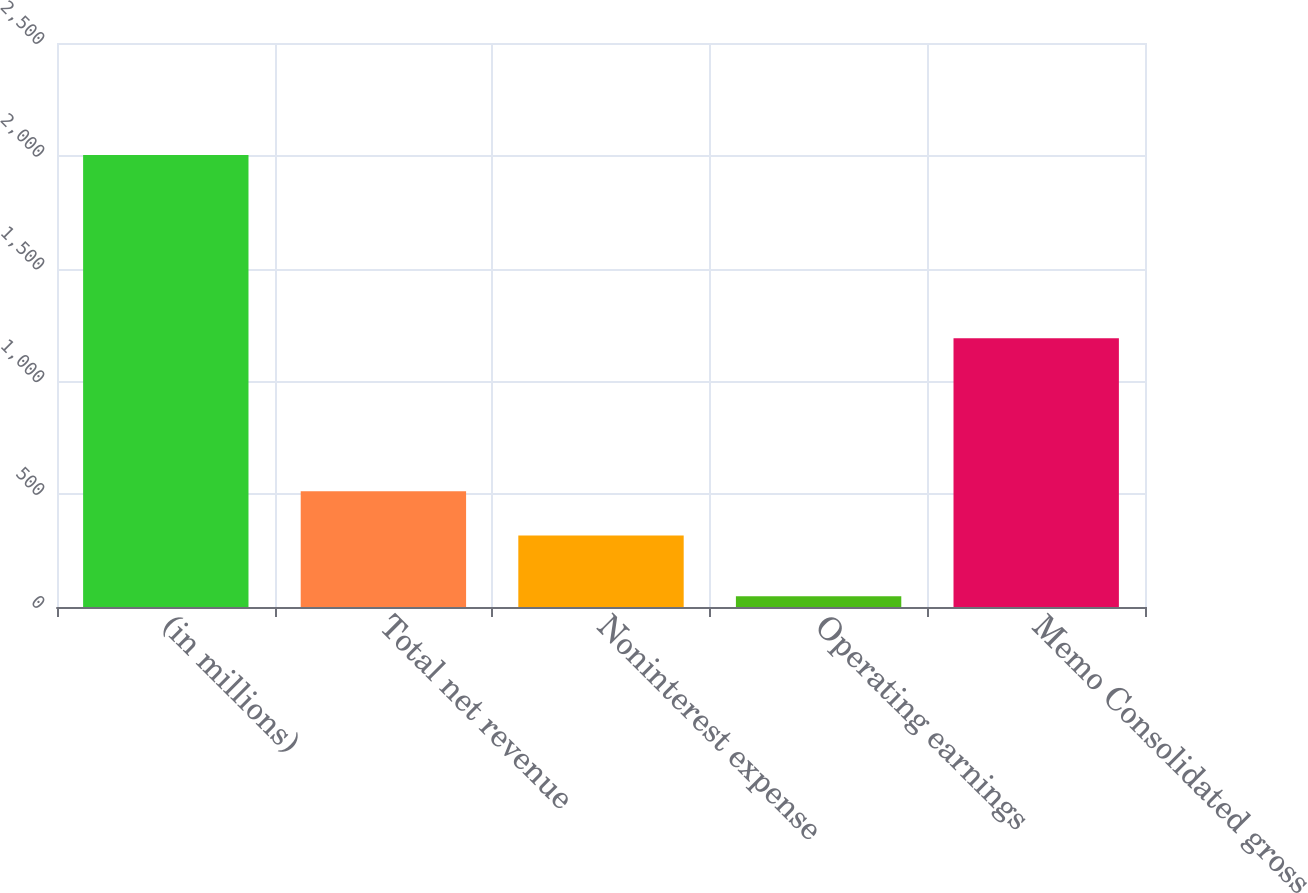<chart> <loc_0><loc_0><loc_500><loc_500><bar_chart><fcel>(in millions)<fcel>Total net revenue<fcel>Noninterest expense<fcel>Operating earnings<fcel>Memo Consolidated gross<nl><fcel>2004<fcel>512.6<fcel>317<fcel>48<fcel>1191<nl></chart> 